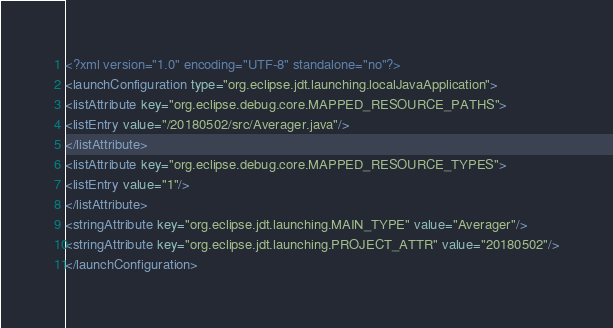<code> <loc_0><loc_0><loc_500><loc_500><_XML_><?xml version="1.0" encoding="UTF-8" standalone="no"?>
<launchConfiguration type="org.eclipse.jdt.launching.localJavaApplication">
<listAttribute key="org.eclipse.debug.core.MAPPED_RESOURCE_PATHS">
<listEntry value="/20180502/src/Averager.java"/>
</listAttribute>
<listAttribute key="org.eclipse.debug.core.MAPPED_RESOURCE_TYPES">
<listEntry value="1"/>
</listAttribute>
<stringAttribute key="org.eclipse.jdt.launching.MAIN_TYPE" value="Averager"/>
<stringAttribute key="org.eclipse.jdt.launching.PROJECT_ATTR" value="20180502"/>
</launchConfiguration>
</code> 